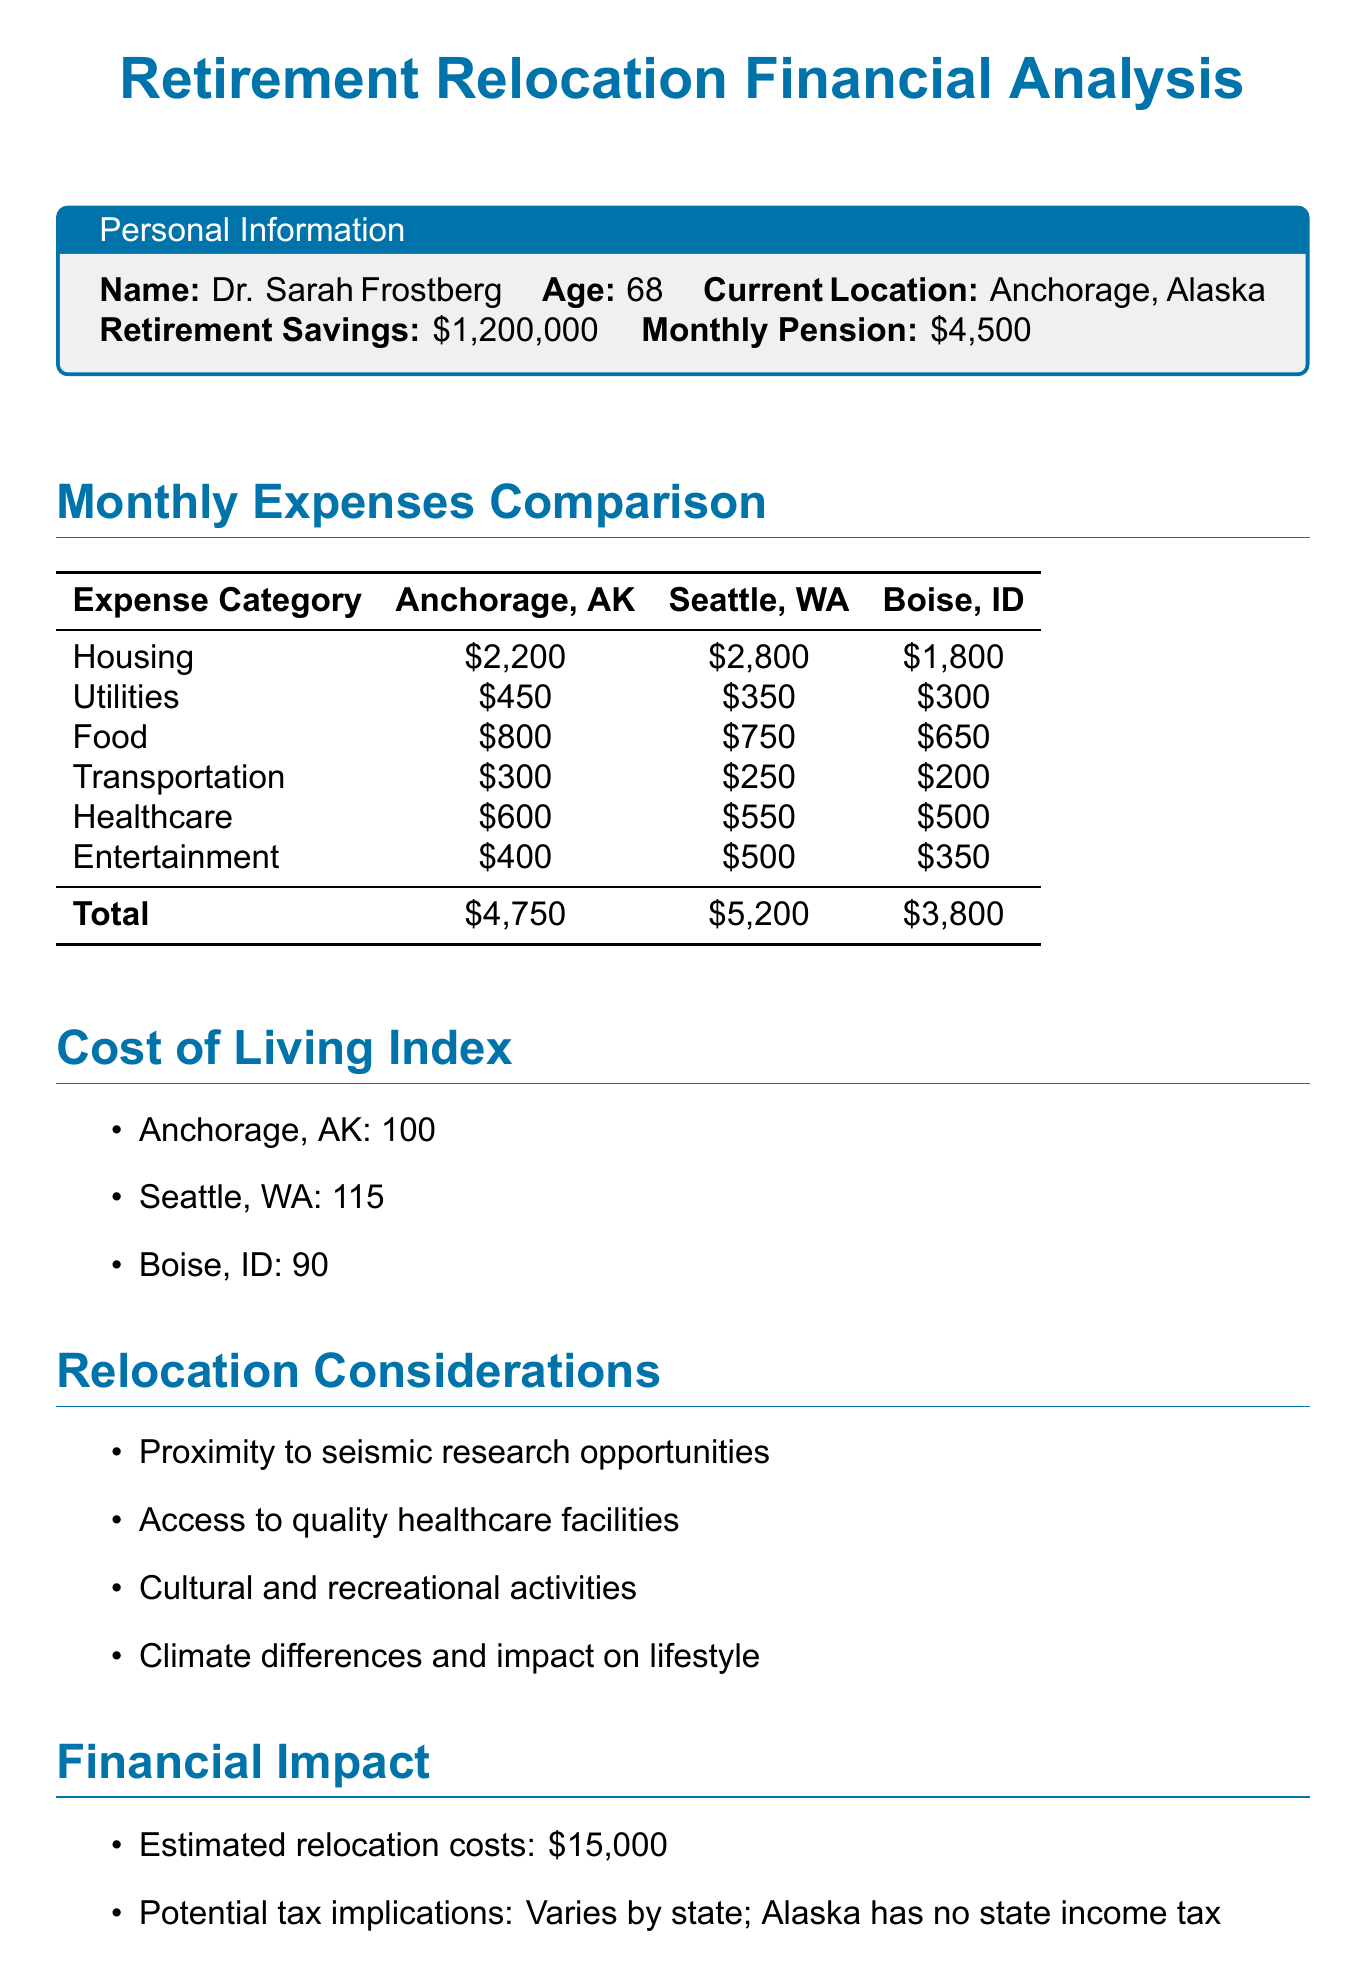What is the total monthly expense in Anchorage? The total monthly expense in Anchorage is calculated by adding all expense categories, which totals $4,750.
Answer: $4,750 What is the estimated relocation cost? The document states that the estimated relocation costs are $15,000.
Answer: $15,000 Which city has the highest cost of living index? The cost of living index for Seattle is 115, which is higher than Anchorage and Boise.
Answer: Seattle What is the monthly pension amount? The document specifies that the monthly pension is $4,500.
Answer: $4,500 Which potential relocation destination has the lowest monthly expenses? The total monthly expense in Boise is $3,800, which is the lowest among the listed destinations.
Answer: Boise What is the healthcare expense in Seattle? The healthcare expense in Seattle is listed as $550.
Answer: $550 Which city is associated with having no state income tax? The document mentions that Alaska has no state income tax.
Answer: Alaska What considerations are included for relocation? The document lists factors such as proximity to seismic research opportunities and access to quality healthcare facilities.
Answer: Proximity to seismic research opportunities What is the entertainment expense in Boise? The entertainment expense in Boise is stated as $350.
Answer: $350 